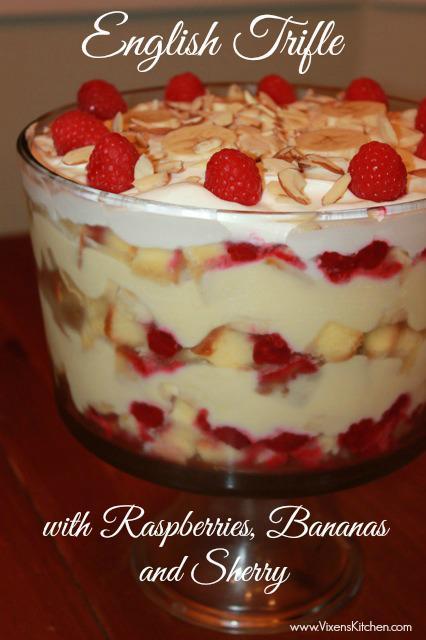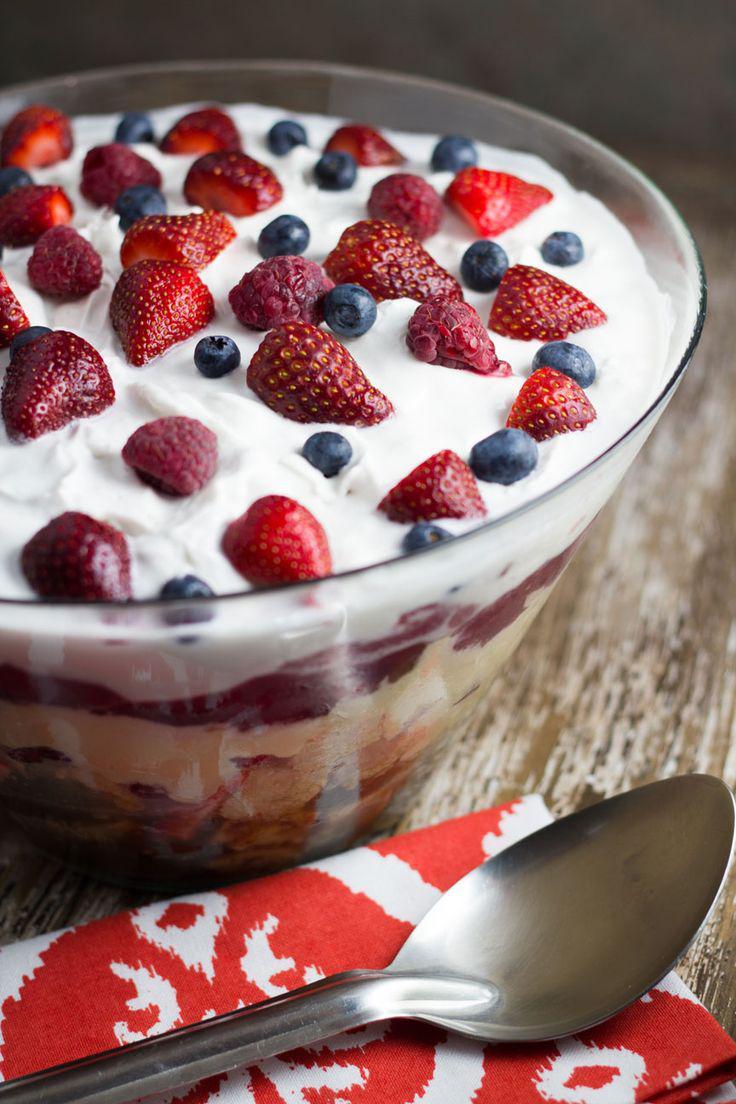The first image is the image on the left, the second image is the image on the right. Given the left and right images, does the statement "there are blueberries on the top of the dessert in one of the images." hold true? Answer yes or no. Yes. The first image is the image on the left, the second image is the image on the right. Analyze the images presented: Is the assertion "Strawberries and blueberries top one of the desserts depicted." valid? Answer yes or no. Yes. 